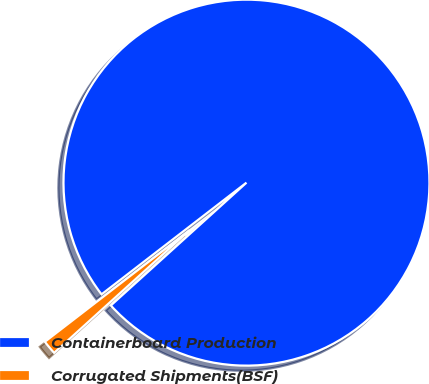<chart> <loc_0><loc_0><loc_500><loc_500><pie_chart><fcel>Containerboard Production<fcel>Corrugated Shipments(BSF)<nl><fcel>98.74%<fcel>1.26%<nl></chart> 